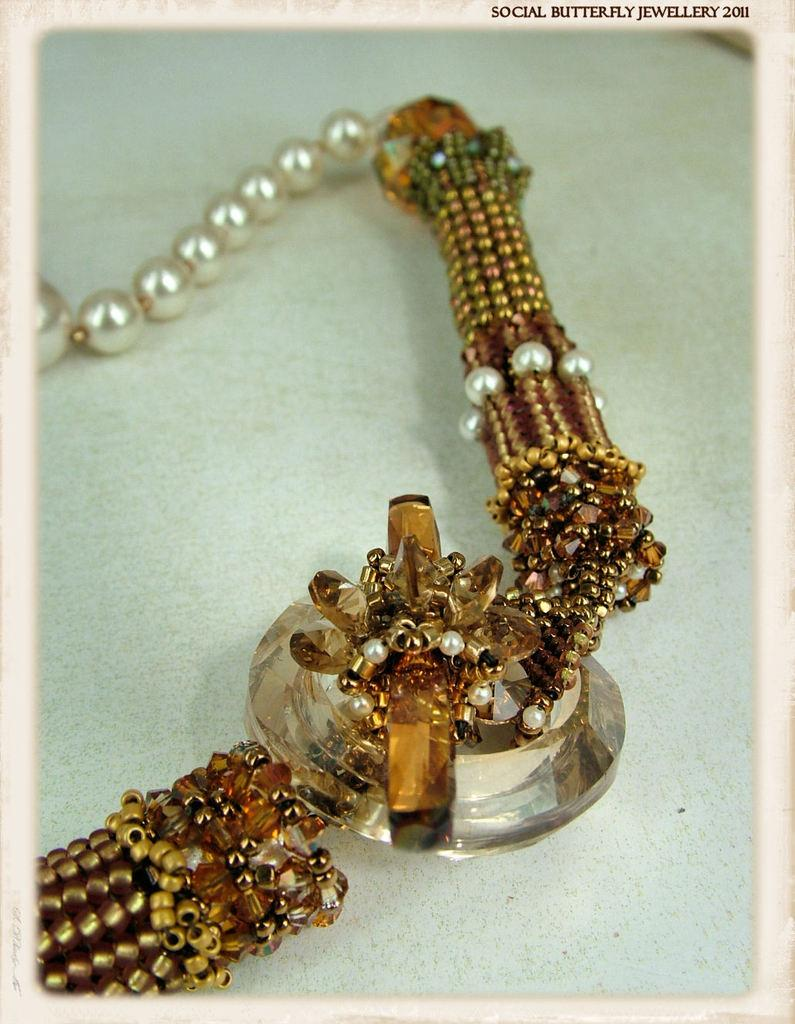What is the main object in the image? The main object in the image is a chain. What is the chain placed on? The chain is on a surface. What type of decorations are on the chain? The chain has pearls, beads, and a stone. What type of harmony does the carpenter achieve with the pet in the image? There is no carpenter or pet present in the image; it only features a chain with pearls, beads, and a stone. 